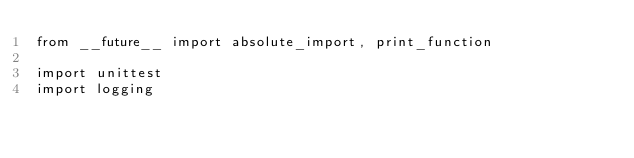<code> <loc_0><loc_0><loc_500><loc_500><_Python_>from __future__ import absolute_import, print_function

import unittest
import logging
</code> 